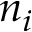Convert formula to latex. <formula><loc_0><loc_0><loc_500><loc_500>n _ { i }</formula> 